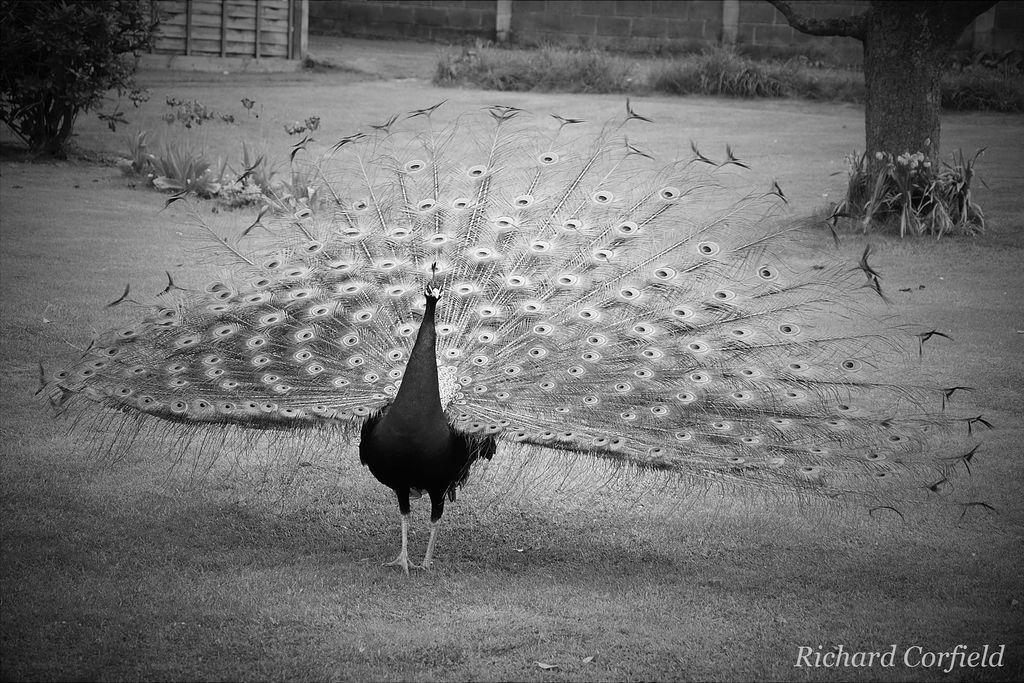What type of picture is in the image? The image contains a black and white picture. What is the subject of the picture? The picture depicts a peacock standing on the ground. What can be seen in the background of the picture? There is grass, trees, and walls visible in the background of the picture. What type of loaf is being served by the minister in the image? There is no minister or loaf present in the image; it features a black and white picture of a peacock standing on the ground. Can you tell me how many copies of the peacock picture are visible in the image? There is only one copy of the peacock picture visible in the image. 